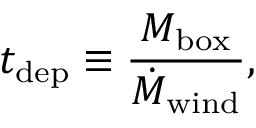Convert formula to latex. <formula><loc_0><loc_0><loc_500><loc_500>t _ { d e p } \equiv \frac { M _ { b o x } } { \dot { M } _ { w i n d } } ,</formula> 